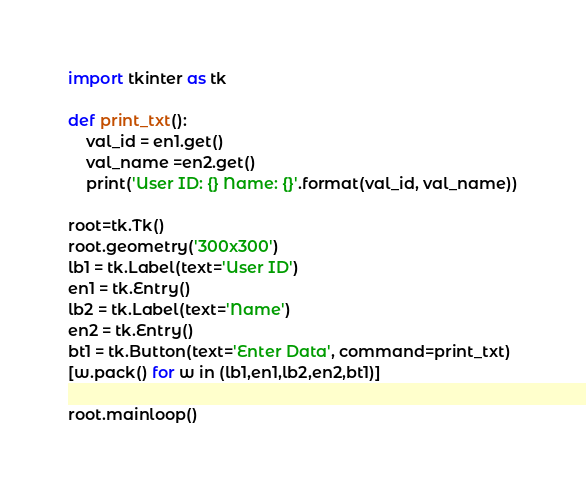<code> <loc_0><loc_0><loc_500><loc_500><_Python_>import tkinter as tk

def print_txt():
    val_id = en1.get()
    val_name =en2.get()
    print('User ID: {} Name: {}'.format(val_id, val_name))

root=tk.Tk()
root.geometry('300x300')
lb1 = tk.Label(text='User ID')
en1 = tk.Entry()
lb2 = tk.Label(text='Name')
en2 = tk.Entry()
bt1 = tk.Button(text='Enter Data', command=print_txt)
[w.pack() for w in (lb1,en1,lb2,en2,bt1)]

root.mainloop()</code> 